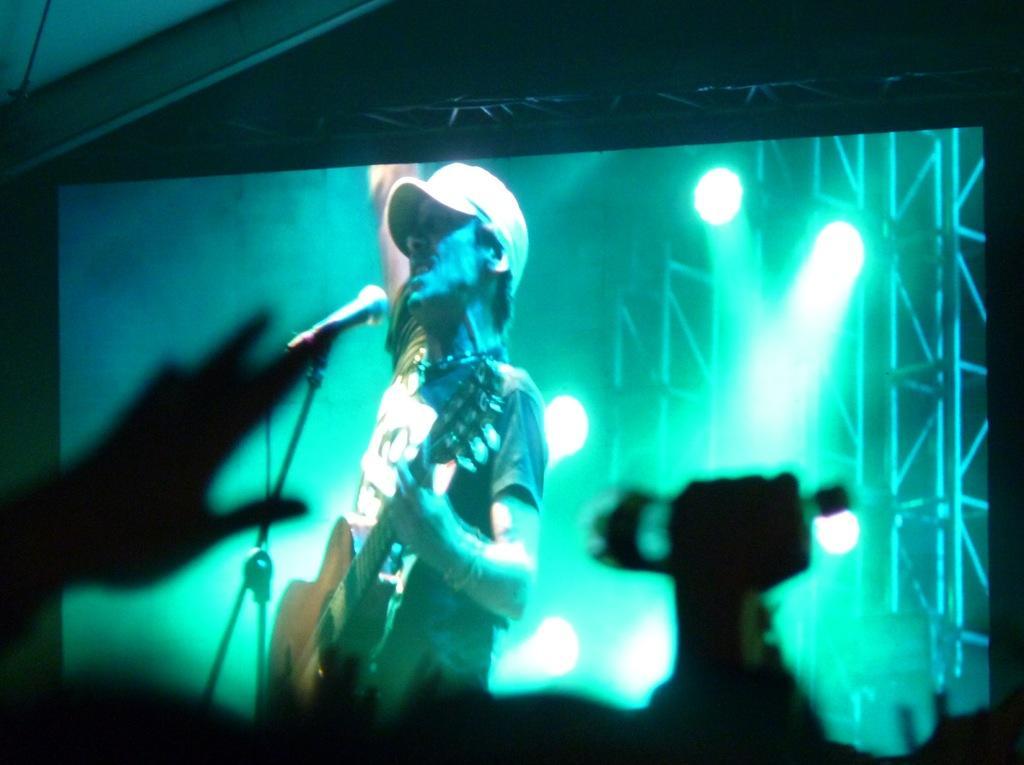Describe this image in one or two sentences. In the image we can see there is a projector screen on which there is a person standing and holding guitar in his hand. In front of him there is a mic with a stand and he is wearing a cap. Behind there are lightings. 